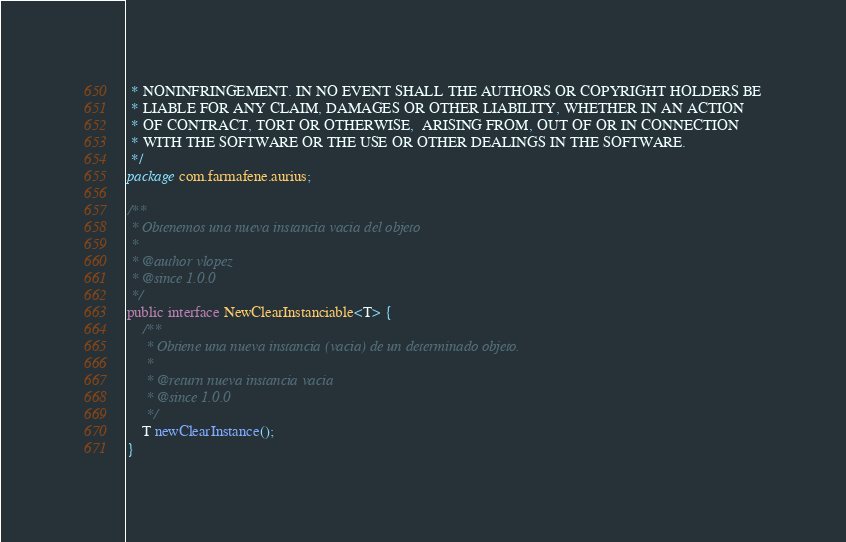<code> <loc_0><loc_0><loc_500><loc_500><_Java_> * NONINFRINGEMENT. IN NO EVENT SHALL THE AUTHORS OR COPYRIGHT HOLDERS BE
 * LIABLE FOR ANY CLAIM, DAMAGES OR OTHER LIABILITY, WHETHER IN AN ACTION
 * OF CONTRACT, TORT OR OTHERWISE,  ARISING FROM, OUT OF OR IN CONNECTION
 * WITH THE SOFTWARE OR THE USE OR OTHER DEALINGS IN THE SOFTWARE.
 */
package com.farmafene.aurius;

/**
 * Obtenemos una nueva instancia vacia del objeto
 * 
 * @author vlopez
 * @since 1.0.0
 */
public interface NewClearInstanciable<T> {
	/**
	 * Obtiene una nueva instancia (vacia) de un determinado objeto.
	 * 
	 * @return nueva instancia vacia
	 * @since 1.0.0
	 */
	T newClearInstance();
}</code> 